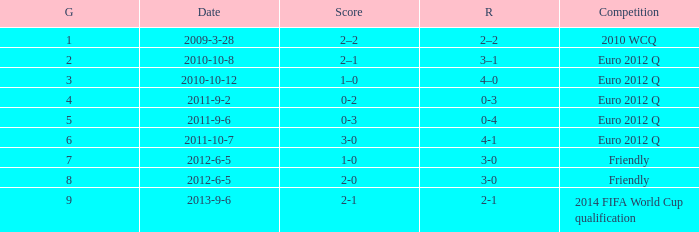What is the result when the score is 0-2? 0-3. 